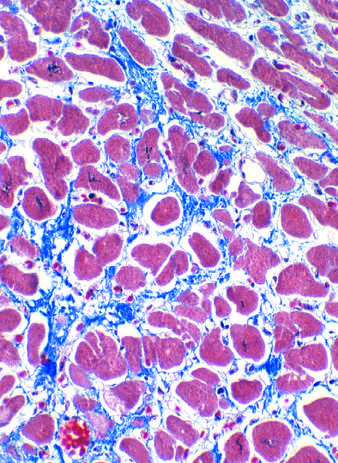s collagen blue in this masson trichrome-stained preparation?
Answer the question using a single word or phrase. Yes 